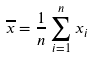<formula> <loc_0><loc_0><loc_500><loc_500>\overline { x } = \frac { 1 } { n } \sum _ { i = 1 } ^ { n } x _ { i }</formula> 